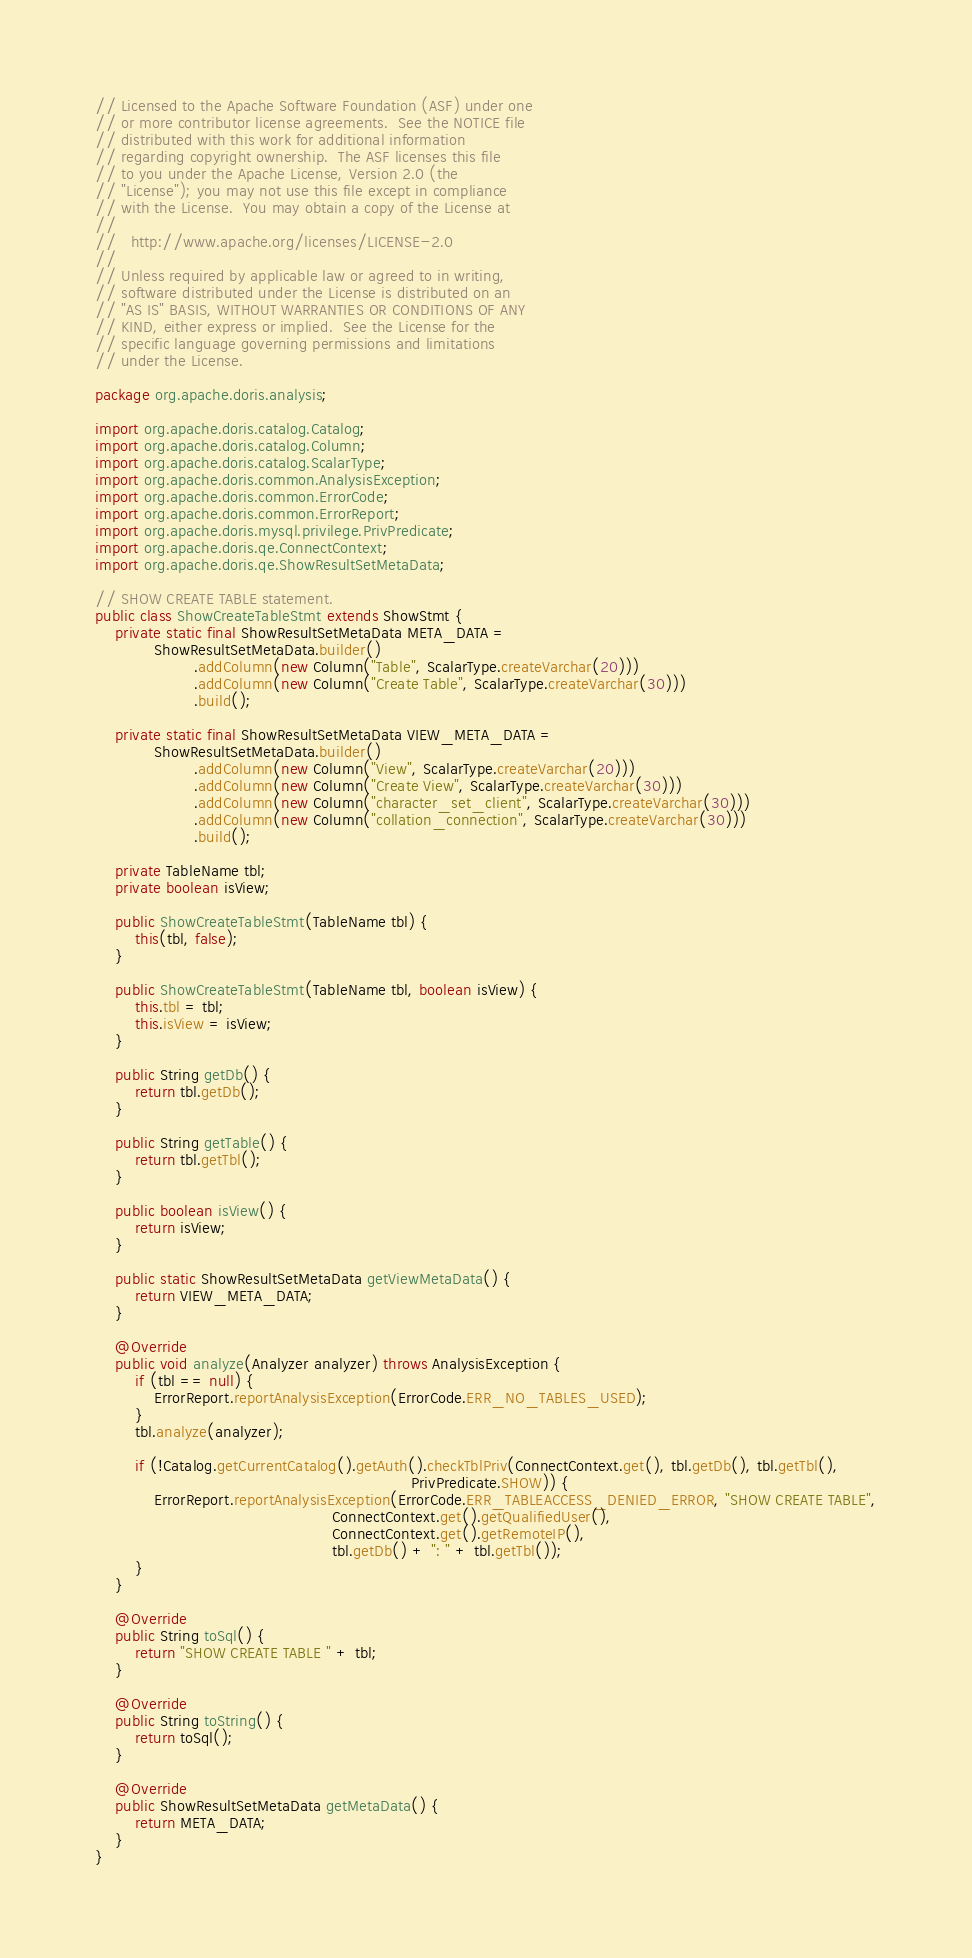<code> <loc_0><loc_0><loc_500><loc_500><_Java_>// Licensed to the Apache Software Foundation (ASF) under one
// or more contributor license agreements.  See the NOTICE file
// distributed with this work for additional information
// regarding copyright ownership.  The ASF licenses this file
// to you under the Apache License, Version 2.0 (the
// "License"); you may not use this file except in compliance
// with the License.  You may obtain a copy of the License at
//
//   http://www.apache.org/licenses/LICENSE-2.0
//
// Unless required by applicable law or agreed to in writing,
// software distributed under the License is distributed on an
// "AS IS" BASIS, WITHOUT WARRANTIES OR CONDITIONS OF ANY
// KIND, either express or implied.  See the License for the
// specific language governing permissions and limitations
// under the License.

package org.apache.doris.analysis;

import org.apache.doris.catalog.Catalog;
import org.apache.doris.catalog.Column;
import org.apache.doris.catalog.ScalarType;
import org.apache.doris.common.AnalysisException;
import org.apache.doris.common.ErrorCode;
import org.apache.doris.common.ErrorReport;
import org.apache.doris.mysql.privilege.PrivPredicate;
import org.apache.doris.qe.ConnectContext;
import org.apache.doris.qe.ShowResultSetMetaData;

// SHOW CREATE TABLE statement.
public class ShowCreateTableStmt extends ShowStmt {
    private static final ShowResultSetMetaData META_DATA =
            ShowResultSetMetaData.builder()
                    .addColumn(new Column("Table", ScalarType.createVarchar(20)))
                    .addColumn(new Column("Create Table", ScalarType.createVarchar(30)))
                    .build();

    private static final ShowResultSetMetaData VIEW_META_DATA =
            ShowResultSetMetaData.builder()
                    .addColumn(new Column("View", ScalarType.createVarchar(20)))
                    .addColumn(new Column("Create View", ScalarType.createVarchar(30)))
                    .addColumn(new Column("character_set_client", ScalarType.createVarchar(30)))
                    .addColumn(new Column("collation_connection", ScalarType.createVarchar(30)))
                    .build();

    private TableName tbl;
    private boolean isView;

    public ShowCreateTableStmt(TableName tbl) {
        this(tbl, false);
    }

    public ShowCreateTableStmt(TableName tbl, boolean isView) {
        this.tbl = tbl;
        this.isView = isView;
    }

    public String getDb() {
        return tbl.getDb();
    }

    public String getTable() {
        return tbl.getTbl();
    }

    public boolean isView() {
        return isView;
    }

    public static ShowResultSetMetaData getViewMetaData() {
        return VIEW_META_DATA;
    }

    @Override
    public void analyze(Analyzer analyzer) throws AnalysisException {
        if (tbl == null) {
            ErrorReport.reportAnalysisException(ErrorCode.ERR_NO_TABLES_USED);
        }
        tbl.analyze(analyzer);

        if (!Catalog.getCurrentCatalog().getAuth().checkTblPriv(ConnectContext.get(), tbl.getDb(), tbl.getTbl(),
                                                                PrivPredicate.SHOW)) {
            ErrorReport.reportAnalysisException(ErrorCode.ERR_TABLEACCESS_DENIED_ERROR, "SHOW CREATE TABLE",
                                                ConnectContext.get().getQualifiedUser(),
                                                ConnectContext.get().getRemoteIP(),
                                                tbl.getDb() + ": " + tbl.getTbl());
        }
    }

    @Override
    public String toSql() {
        return "SHOW CREATE TABLE " + tbl;
    }

    @Override
    public String toString() {
        return toSql();
    }

    @Override
    public ShowResultSetMetaData getMetaData() {
        return META_DATA;
    }
}
</code> 